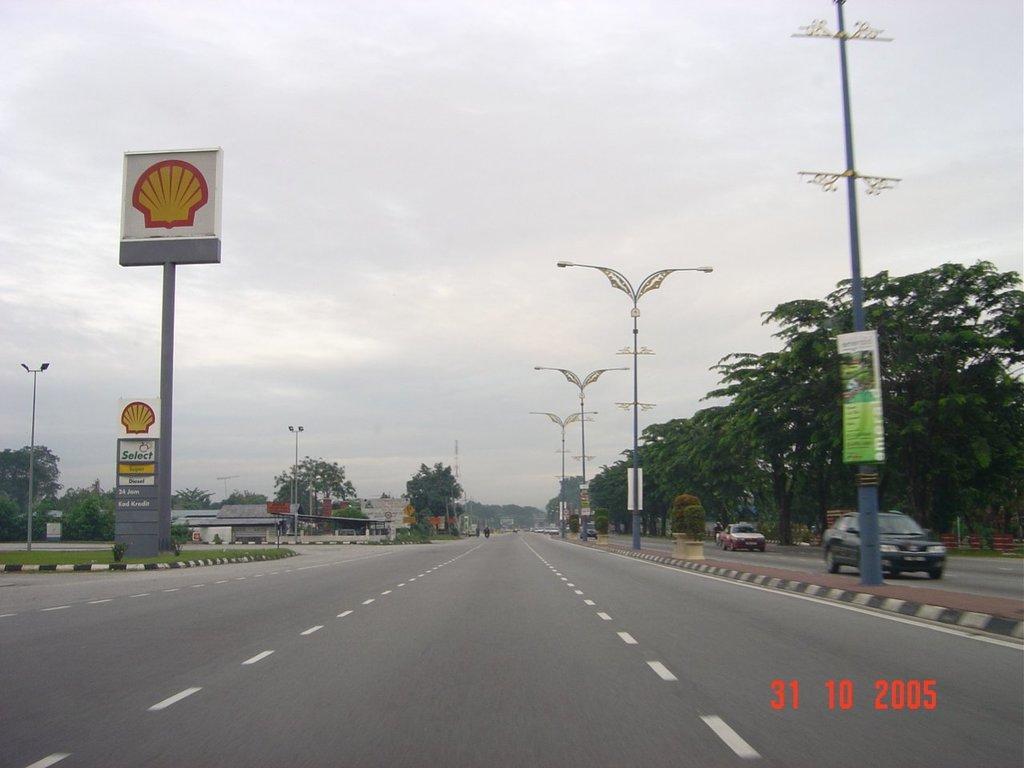Could you give a brief overview of what you see in this image? In the background we can see the sky. In this picture we can see the vehicles on the road. We can see trees, lights, poles, boards, plants, grass. In the bottom left corner of the picture we can see the date. In the middle portion of the picture looks like a person riding a vehicle. 